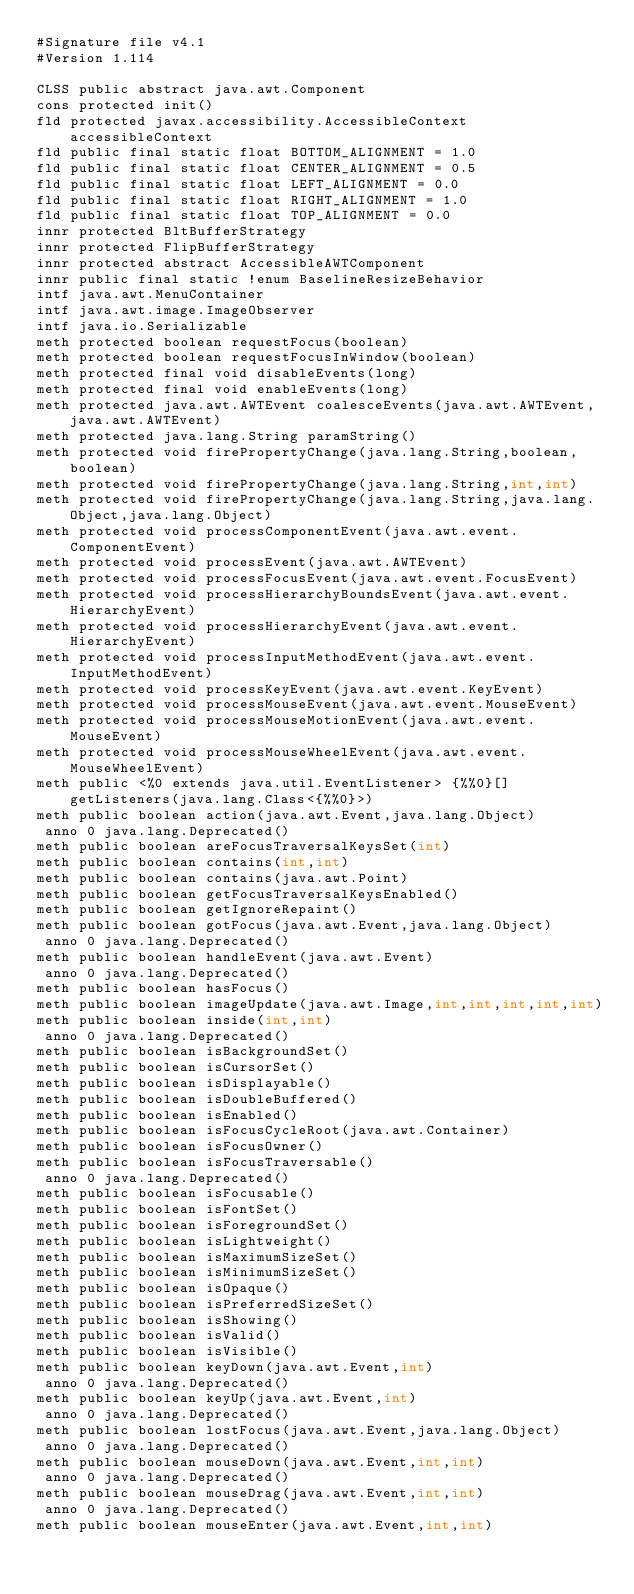Convert code to text. <code><loc_0><loc_0><loc_500><loc_500><_SML_>#Signature file v4.1
#Version 1.114

CLSS public abstract java.awt.Component
cons protected init()
fld protected javax.accessibility.AccessibleContext accessibleContext
fld public final static float BOTTOM_ALIGNMENT = 1.0
fld public final static float CENTER_ALIGNMENT = 0.5
fld public final static float LEFT_ALIGNMENT = 0.0
fld public final static float RIGHT_ALIGNMENT = 1.0
fld public final static float TOP_ALIGNMENT = 0.0
innr protected BltBufferStrategy
innr protected FlipBufferStrategy
innr protected abstract AccessibleAWTComponent
innr public final static !enum BaselineResizeBehavior
intf java.awt.MenuContainer
intf java.awt.image.ImageObserver
intf java.io.Serializable
meth protected boolean requestFocus(boolean)
meth protected boolean requestFocusInWindow(boolean)
meth protected final void disableEvents(long)
meth protected final void enableEvents(long)
meth protected java.awt.AWTEvent coalesceEvents(java.awt.AWTEvent,java.awt.AWTEvent)
meth protected java.lang.String paramString()
meth protected void firePropertyChange(java.lang.String,boolean,boolean)
meth protected void firePropertyChange(java.lang.String,int,int)
meth protected void firePropertyChange(java.lang.String,java.lang.Object,java.lang.Object)
meth protected void processComponentEvent(java.awt.event.ComponentEvent)
meth protected void processEvent(java.awt.AWTEvent)
meth protected void processFocusEvent(java.awt.event.FocusEvent)
meth protected void processHierarchyBoundsEvent(java.awt.event.HierarchyEvent)
meth protected void processHierarchyEvent(java.awt.event.HierarchyEvent)
meth protected void processInputMethodEvent(java.awt.event.InputMethodEvent)
meth protected void processKeyEvent(java.awt.event.KeyEvent)
meth protected void processMouseEvent(java.awt.event.MouseEvent)
meth protected void processMouseMotionEvent(java.awt.event.MouseEvent)
meth protected void processMouseWheelEvent(java.awt.event.MouseWheelEvent)
meth public <%0 extends java.util.EventListener> {%%0}[] getListeners(java.lang.Class<{%%0}>)
meth public boolean action(java.awt.Event,java.lang.Object)
 anno 0 java.lang.Deprecated()
meth public boolean areFocusTraversalKeysSet(int)
meth public boolean contains(int,int)
meth public boolean contains(java.awt.Point)
meth public boolean getFocusTraversalKeysEnabled()
meth public boolean getIgnoreRepaint()
meth public boolean gotFocus(java.awt.Event,java.lang.Object)
 anno 0 java.lang.Deprecated()
meth public boolean handleEvent(java.awt.Event)
 anno 0 java.lang.Deprecated()
meth public boolean hasFocus()
meth public boolean imageUpdate(java.awt.Image,int,int,int,int,int)
meth public boolean inside(int,int)
 anno 0 java.lang.Deprecated()
meth public boolean isBackgroundSet()
meth public boolean isCursorSet()
meth public boolean isDisplayable()
meth public boolean isDoubleBuffered()
meth public boolean isEnabled()
meth public boolean isFocusCycleRoot(java.awt.Container)
meth public boolean isFocusOwner()
meth public boolean isFocusTraversable()
 anno 0 java.lang.Deprecated()
meth public boolean isFocusable()
meth public boolean isFontSet()
meth public boolean isForegroundSet()
meth public boolean isLightweight()
meth public boolean isMaximumSizeSet()
meth public boolean isMinimumSizeSet()
meth public boolean isOpaque()
meth public boolean isPreferredSizeSet()
meth public boolean isShowing()
meth public boolean isValid()
meth public boolean isVisible()
meth public boolean keyDown(java.awt.Event,int)
 anno 0 java.lang.Deprecated()
meth public boolean keyUp(java.awt.Event,int)
 anno 0 java.lang.Deprecated()
meth public boolean lostFocus(java.awt.Event,java.lang.Object)
 anno 0 java.lang.Deprecated()
meth public boolean mouseDown(java.awt.Event,int,int)
 anno 0 java.lang.Deprecated()
meth public boolean mouseDrag(java.awt.Event,int,int)
 anno 0 java.lang.Deprecated()
meth public boolean mouseEnter(java.awt.Event,int,int)</code> 